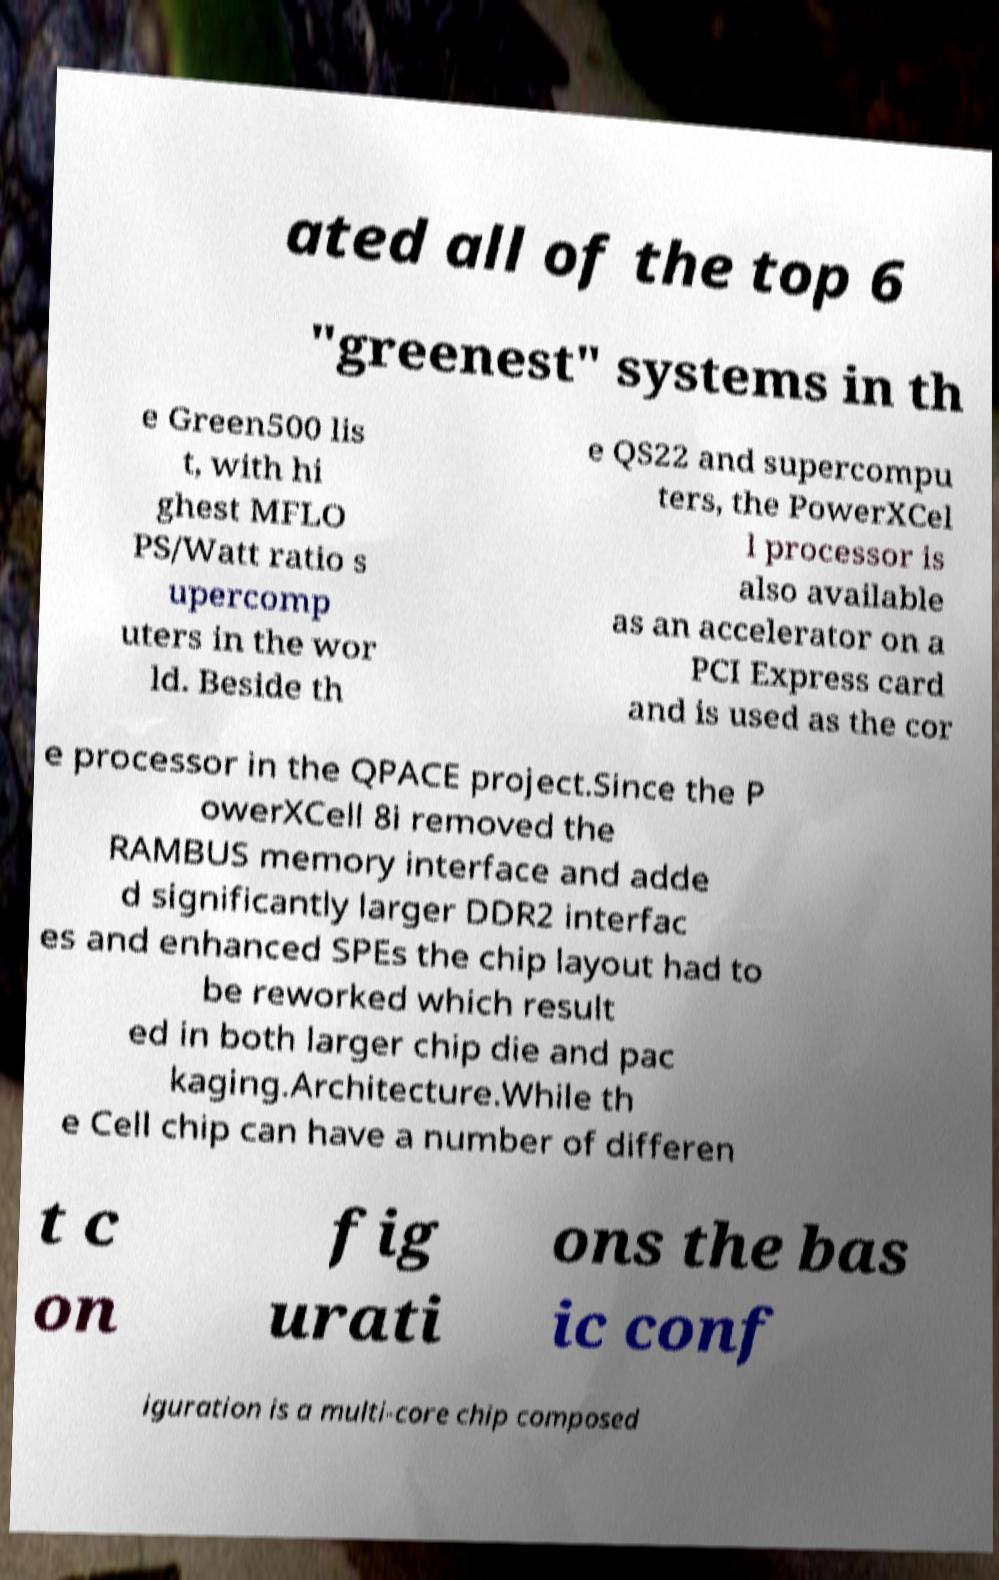Please identify and transcribe the text found in this image. ated all of the top 6 "greenest" systems in th e Green500 lis t, with hi ghest MFLO PS/Watt ratio s upercomp uters in the wor ld. Beside th e QS22 and supercompu ters, the PowerXCel l processor is also available as an accelerator on a PCI Express card and is used as the cor e processor in the QPACE project.Since the P owerXCell 8i removed the RAMBUS memory interface and adde d significantly larger DDR2 interfac es and enhanced SPEs the chip layout had to be reworked which result ed in both larger chip die and pac kaging.Architecture.While th e Cell chip can have a number of differen t c on fig urati ons the bas ic conf iguration is a multi-core chip composed 